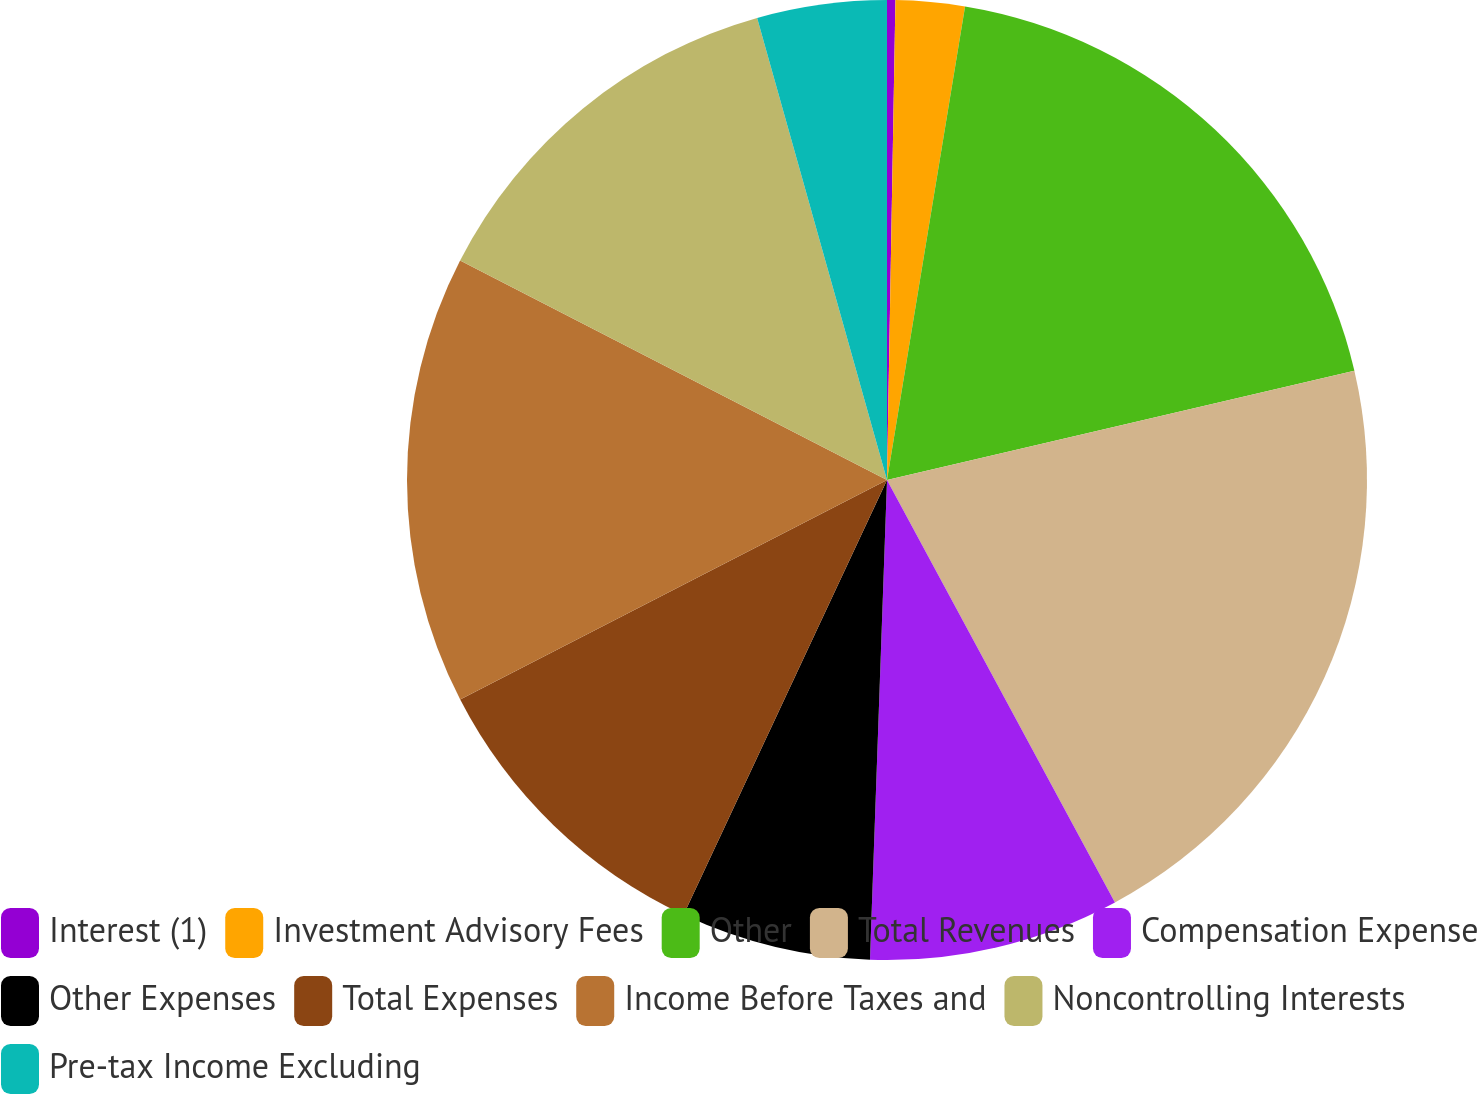Convert chart. <chart><loc_0><loc_0><loc_500><loc_500><pie_chart><fcel>Interest (1)<fcel>Investment Advisory Fees<fcel>Other<fcel>Total Revenues<fcel>Compensation Expense<fcel>Other Expenses<fcel>Total Expenses<fcel>Income Before Taxes and<fcel>Noncontrolling Interests<fcel>Pre-tax Income Excluding<nl><fcel>0.28%<fcel>2.32%<fcel>18.74%<fcel>20.78%<fcel>8.44%<fcel>6.4%<fcel>10.47%<fcel>15.12%<fcel>13.08%<fcel>4.36%<nl></chart> 